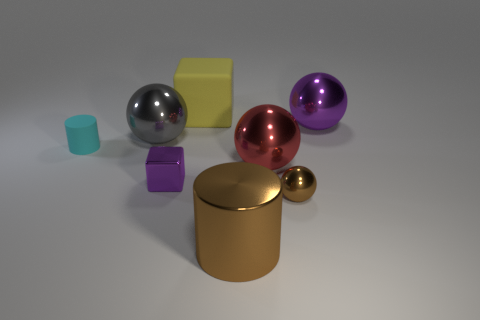Subtract all big shiny balls. How many balls are left? 1 Add 1 large purple metallic spheres. How many objects exist? 9 Subtract all blocks. How many objects are left? 6 Subtract all gray spheres. How many spheres are left? 3 Subtract all red cylinders. Subtract all brown cubes. How many cylinders are left? 2 Add 1 big gray objects. How many big gray objects are left? 2 Add 5 big blue matte balls. How many big blue matte balls exist? 5 Subtract 0 brown cubes. How many objects are left? 8 Subtract 3 balls. How many balls are left? 1 Subtract all small brown rubber blocks. Subtract all big red metal things. How many objects are left? 7 